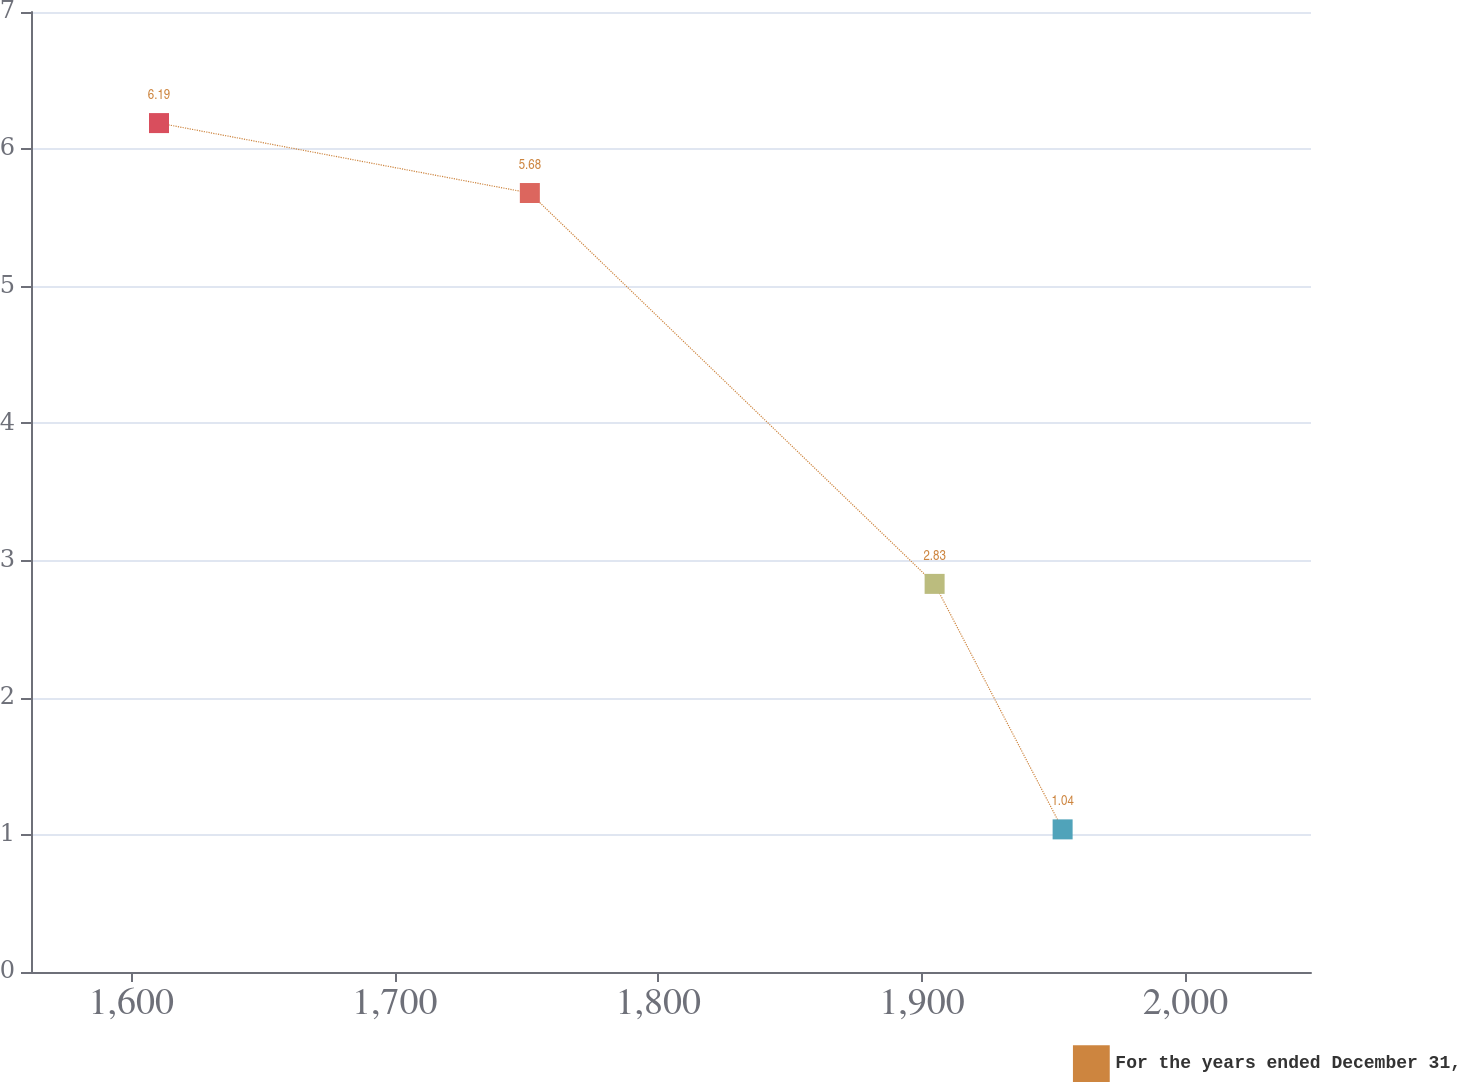Convert chart to OTSL. <chart><loc_0><loc_0><loc_500><loc_500><line_chart><ecel><fcel>For the years ended December 31,<nl><fcel>1610.52<fcel>6.19<nl><fcel>1751.24<fcel>5.68<nl><fcel>1904.83<fcel>2.83<nl><fcel>1953.4<fcel>1.04<nl><fcel>2096.22<fcel>1.55<nl></chart> 